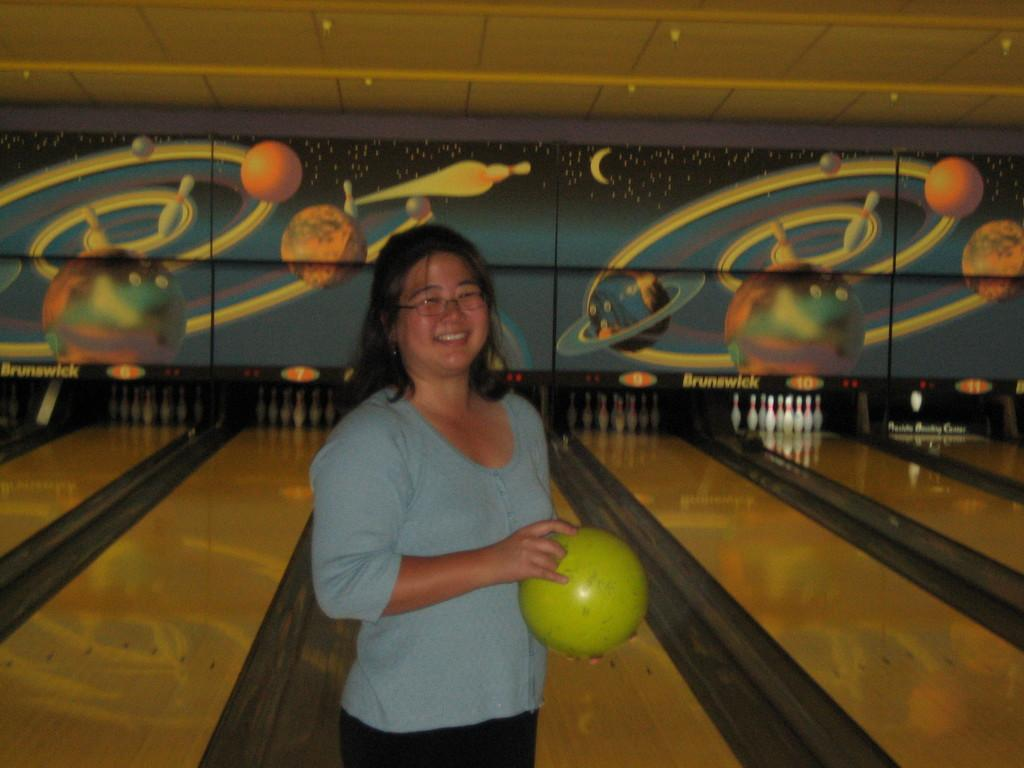What is the person holding in the image? The person is holding a ball in the image. What color is the ball? The ball is green. What is the person wearing? The person is wearing a blue shirt and black pants. What is the person doing in the image? The person is standing in the image. What is visible in the background of the image? The background of the image includes a multicolored wall. How many bikes are visible in the image? There are no bikes present in the image. What type of change does the person undergo in the image? The person does not undergo any change in the image; they are standing still. 